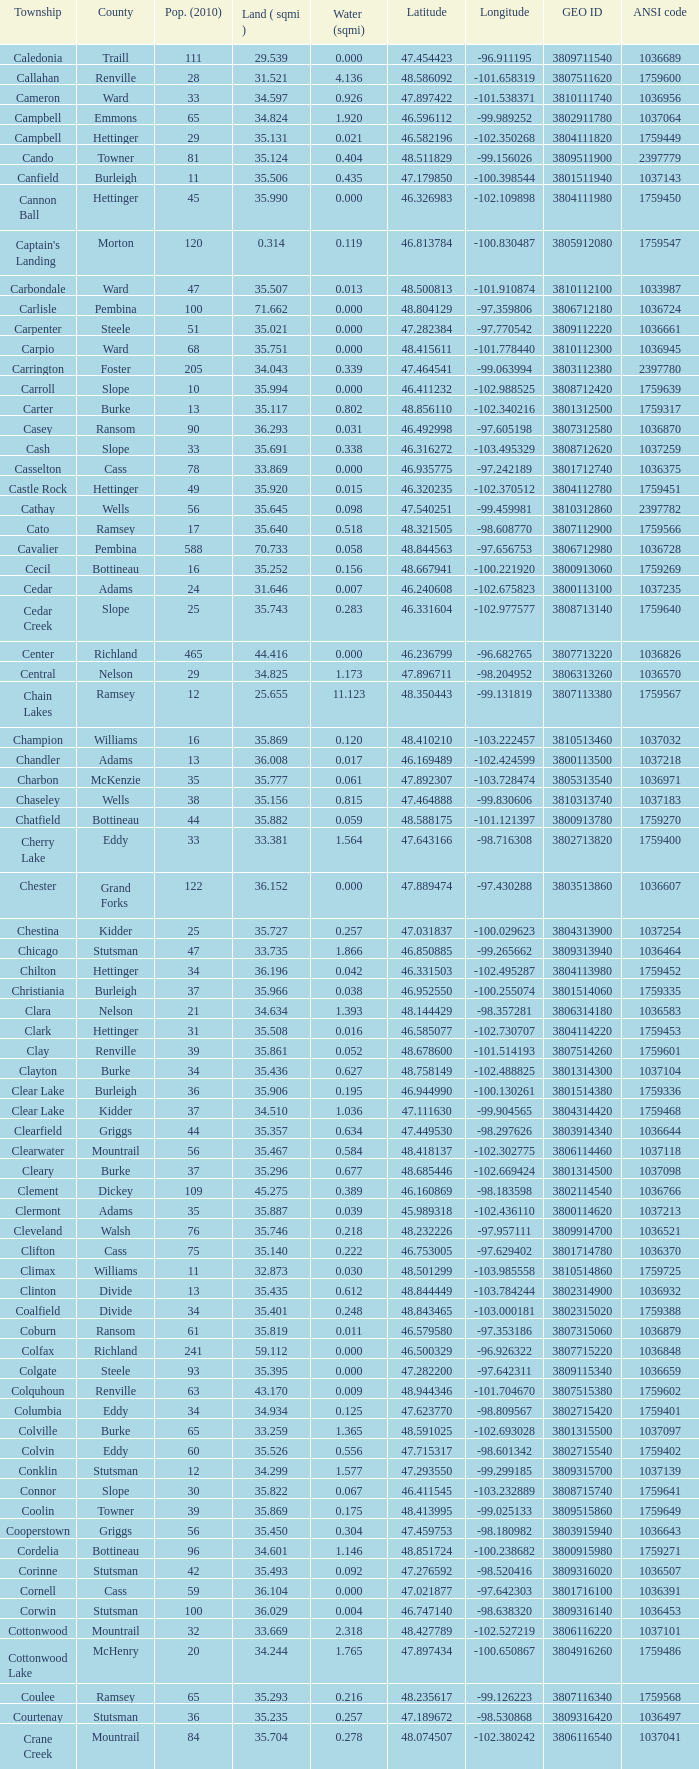Which county had a latitude of 4 Kidder. 